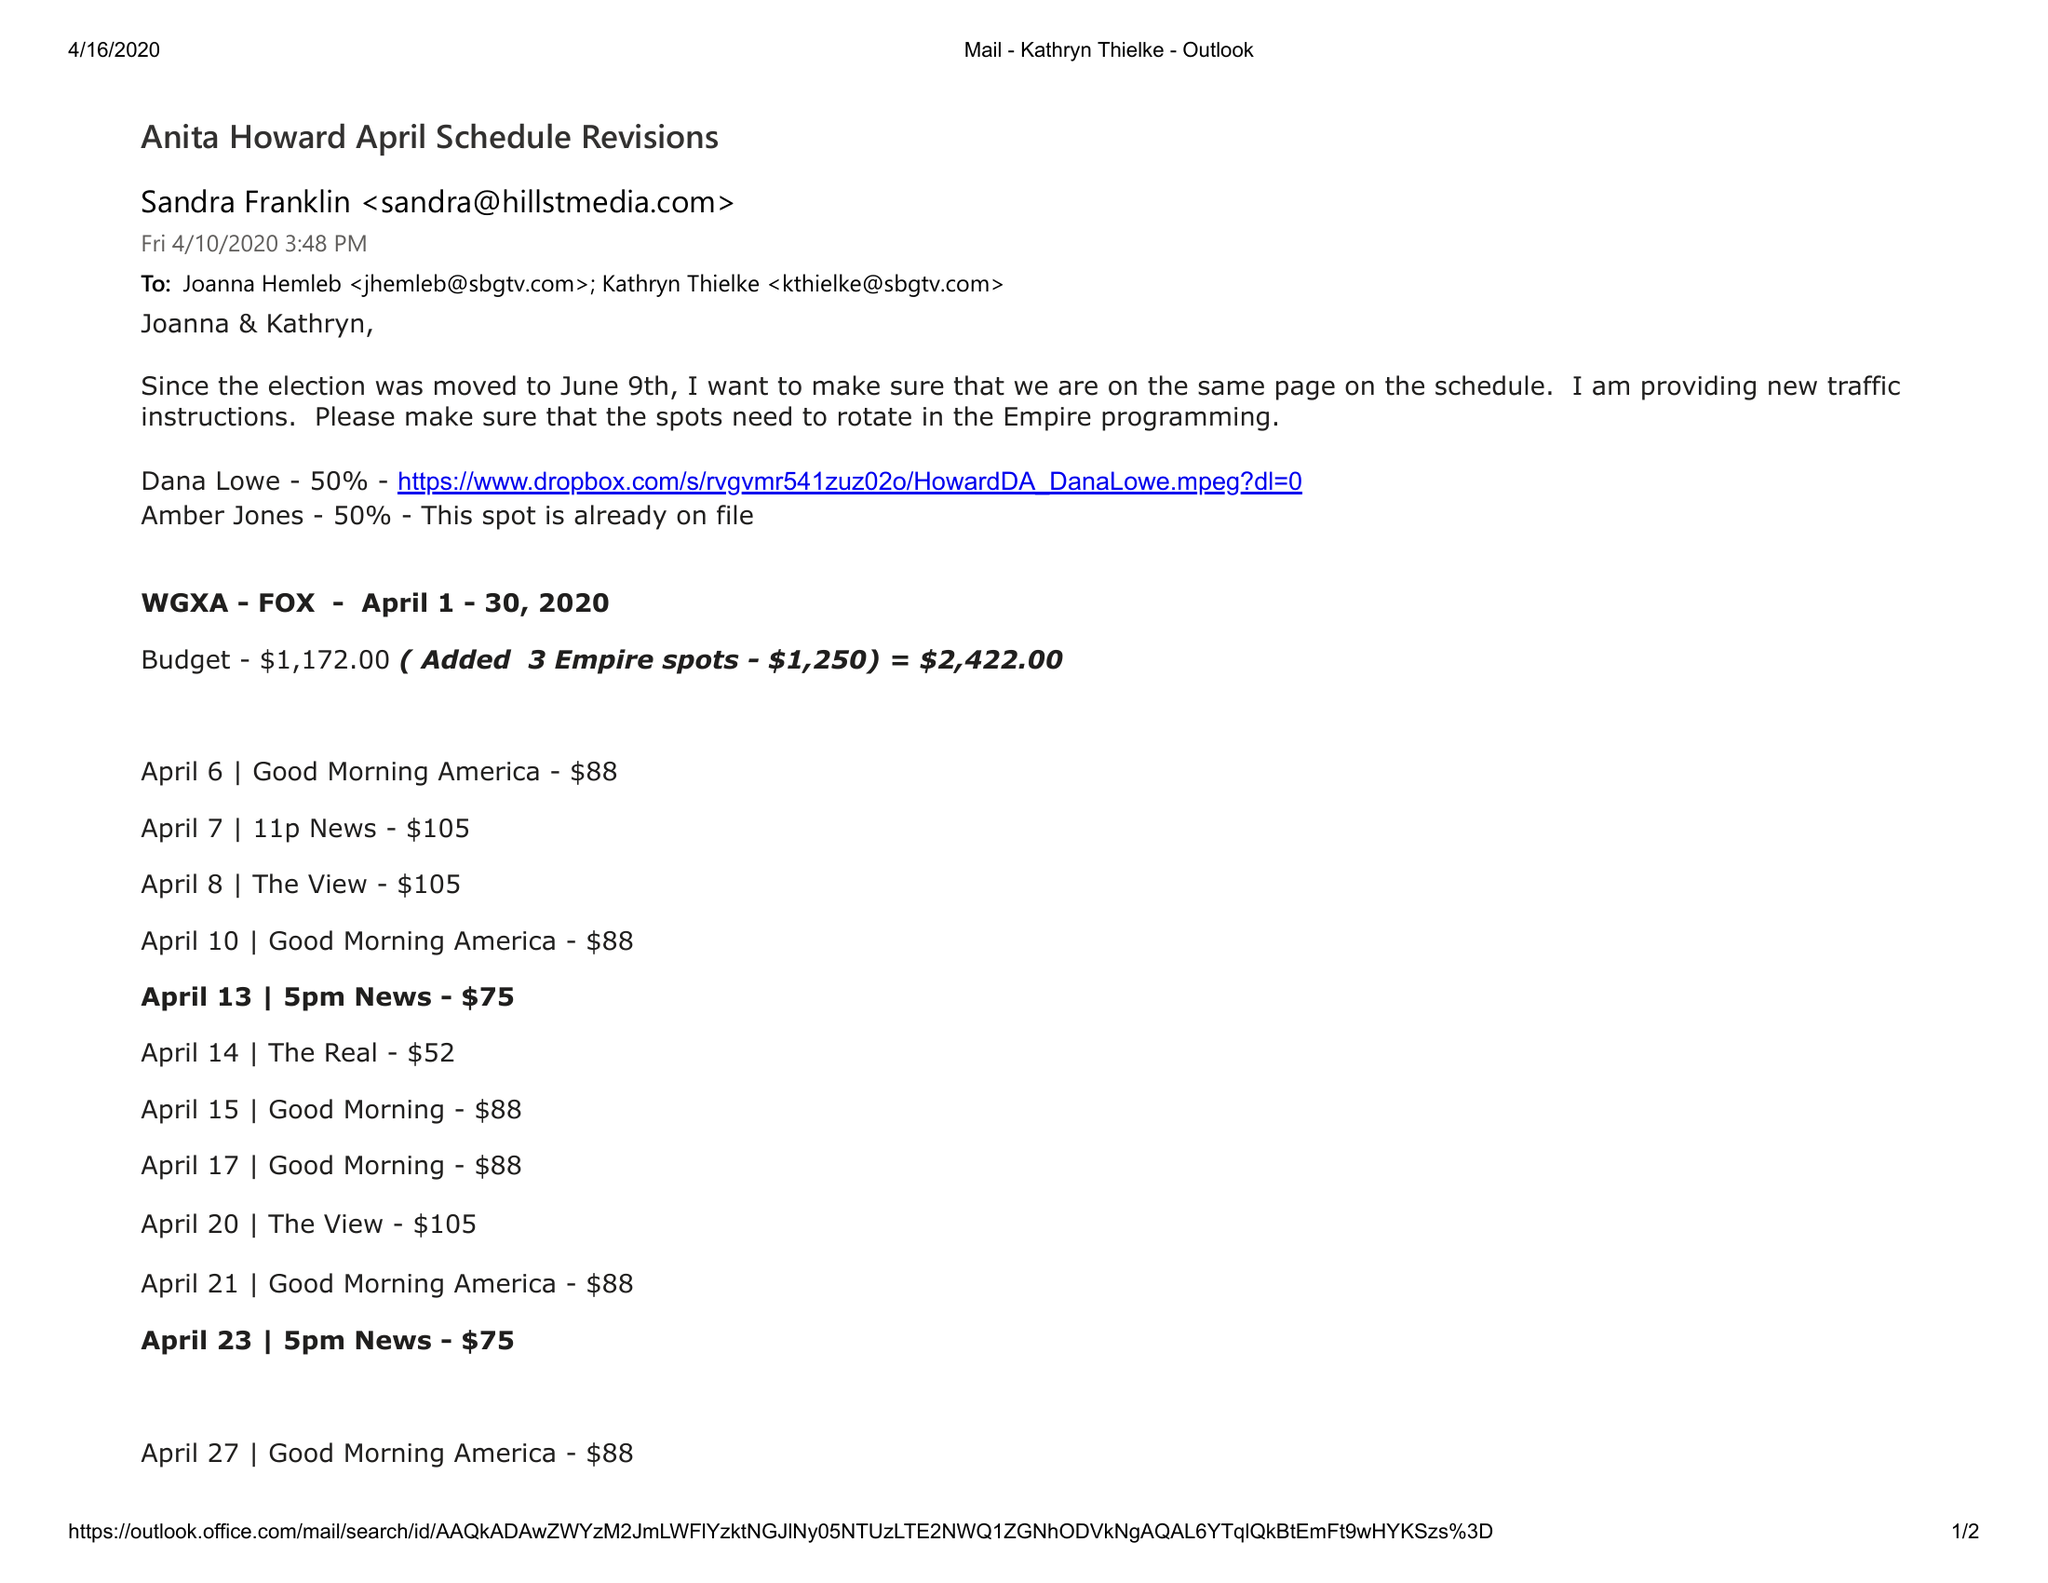What is the value for the flight_to?
Answer the question using a single word or phrase. 04/30/20 